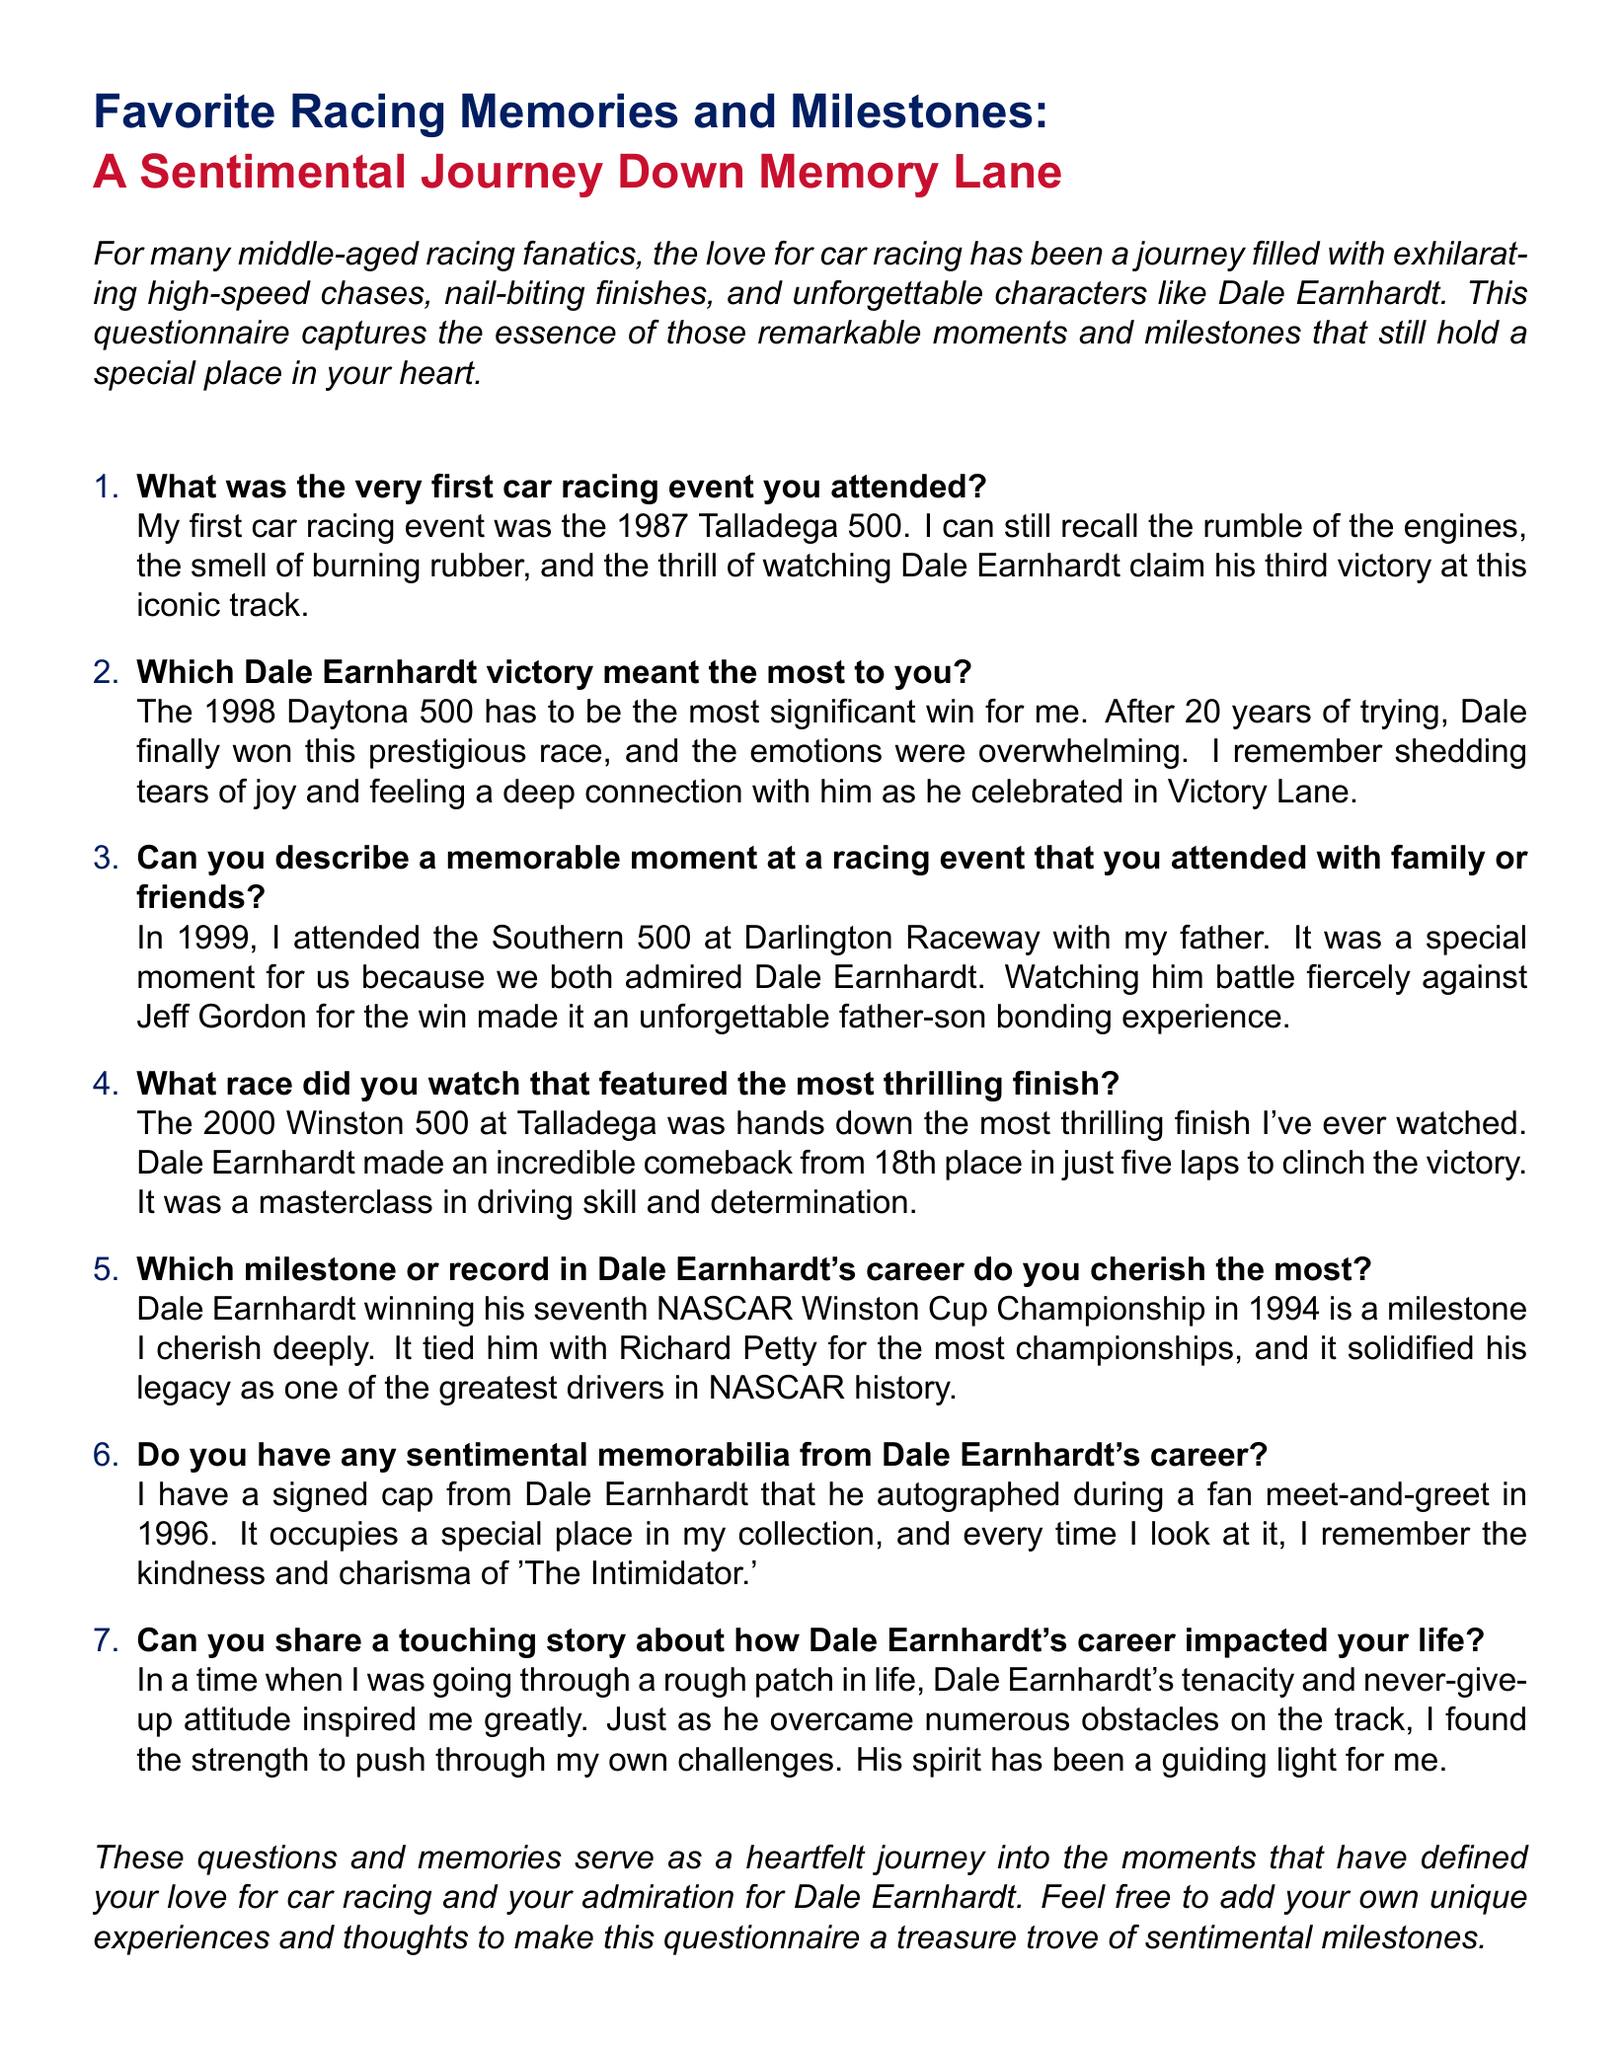What was the first car racing event mentioned? The first event listed in the document is the 1987 Talladega 500, which has notable details concerning Dale Earnhardt's victory.
Answer: 1987 Talladega 500 Which Dale Earnhardt victory is highlighted as the most significant? The document specifically identifies the 1998 Daytona 500 as the victory that meant the most, detailing the emotional connection to it.
Answer: 1998 Daytona 500 What year did the Southern 500 event take place? The document states that the individual attended the Southern 500 in 1999, providing context about the memorable experience with family.
Answer: 1999 What milestone in Dale Earnhardt's career is cherished most? The greatest milestone cherished is Dale Earnhardt winning his seventh NASCAR Winston Cup Championship in 1994, as indicated in the document.
Answer: seventh NASCAR Winston Cup Championship in 1994 What sentimental memorabilia from Dale Earnhardt's career is mentioned? The document notes a signed cap from Dale Earnhardt that was autographed during a fan meet-and-greet in 1996, highlighting its significance.
Answer: signed cap What personal impact did Dale Earnhardt's career have on the individual? The document explains that Dale's tenacity inspired the individual during difficult times, emphasizing how it provided strength during challenges.
Answer: tenacity and never-give-up attitude 